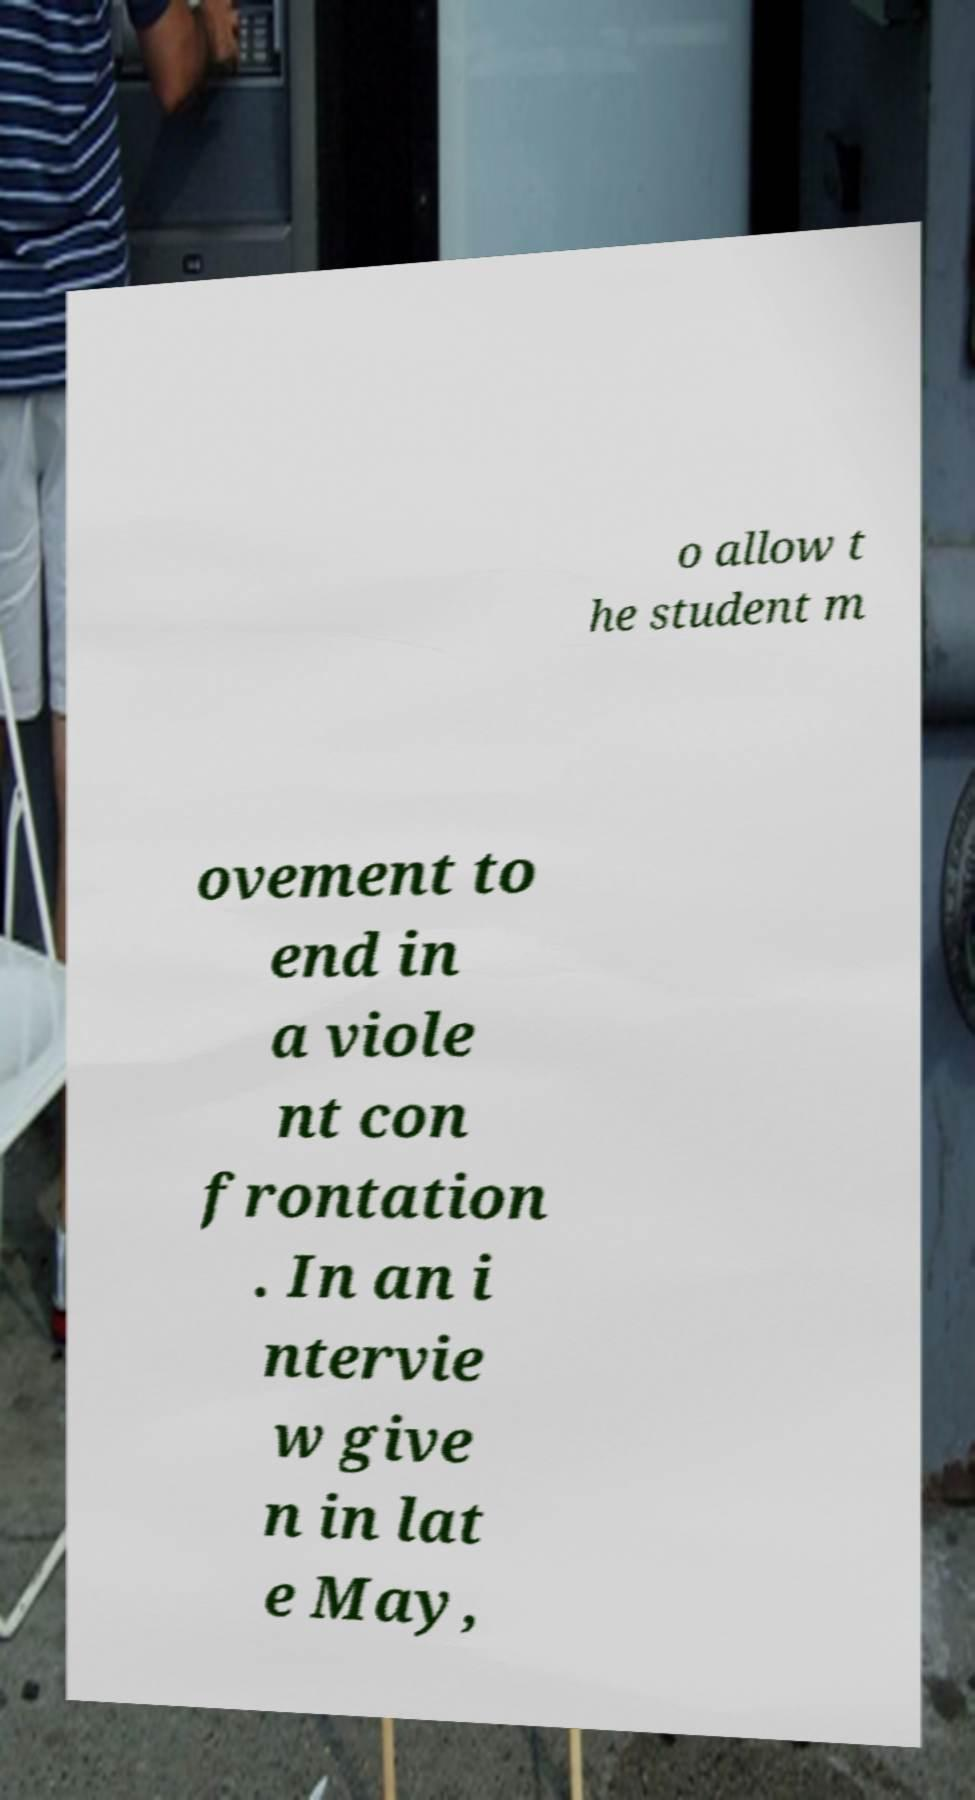Could you extract and type out the text from this image? o allow t he student m ovement to end in a viole nt con frontation . In an i ntervie w give n in lat e May, 